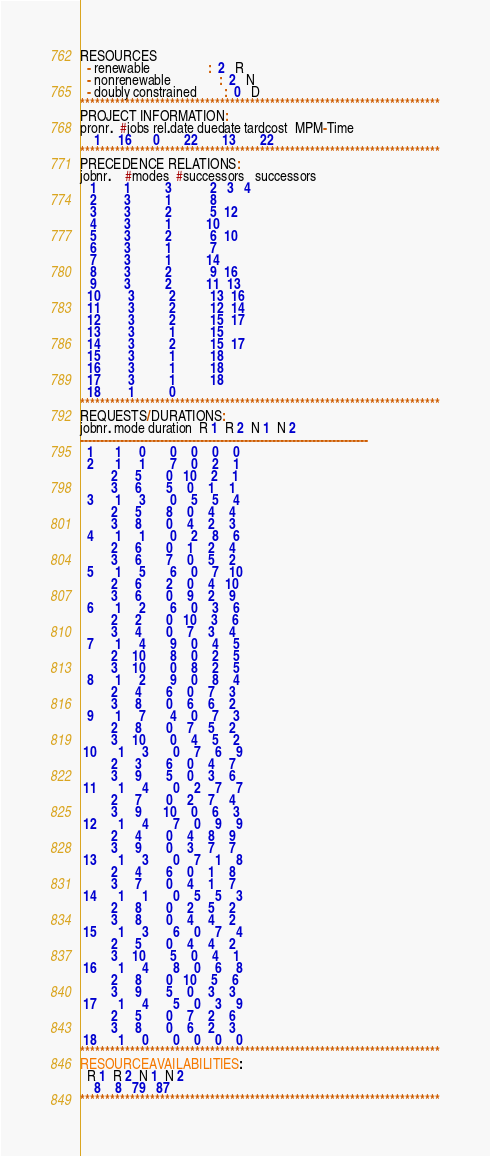Convert code to text. <code><loc_0><loc_0><loc_500><loc_500><_ObjectiveC_>RESOURCES
  - renewable                 :  2   R
  - nonrenewable              :  2   N
  - doubly constrained        :  0   D
************************************************************************
PROJECT INFORMATION:
pronr.  #jobs rel.date duedate tardcost  MPM-Time
    1     16      0       22       13       22
************************************************************************
PRECEDENCE RELATIONS:
jobnr.    #modes  #successors   successors
   1        1          3           2   3   4
   2        3          1           8
   3        3          2           5  12
   4        3          1          10
   5        3          2           6  10
   6        3          1           7
   7        3          1          14
   8        3          2           9  16
   9        3          2          11  13
  10        3          2          13  16
  11        3          2          12  14
  12        3          2          15  17
  13        3          1          15
  14        3          2          15  17
  15        3          1          18
  16        3          1          18
  17        3          1          18
  18        1          0        
************************************************************************
REQUESTS/DURATIONS:
jobnr. mode duration  R 1  R 2  N 1  N 2
------------------------------------------------------------------------
  1      1     0       0    0    0    0
  2      1     1       7    0    2    1
         2     5       0   10    2    1
         3     6       5    0    1    1
  3      1     3       0    5    5    4
         2     5       8    0    4    4
         3     8       0    4    2    3
  4      1     1       0    2    8    6
         2     6       0    1    2    4
         3     6       7    0    5    2
  5      1     5       6    0    7   10
         2     6       2    0    4   10
         3     6       0    9    2    9
  6      1     2       6    0    3    6
         2     2       0   10    3    6
         3     4       0    7    3    4
  7      1     4       9    0    4    5
         2    10       8    0    2    5
         3    10       0    8    2    5
  8      1     2       9    0    8    4
         2     4       6    0    7    3
         3     8       0    6    6    2
  9      1     7       4    0    7    3
         2     8       0    7    5    2
         3    10       0    4    5    2
 10      1     3       0    7    6    9
         2     3       6    0    4    7
         3     9       5    0    3    6
 11      1     4       0    2    7    7
         2     7       0    2    7    4
         3     9      10    0    6    3
 12      1     4       7    0    9    9
         2     4       0    4    8    9
         3     9       0    3    7    7
 13      1     3       0    7    1    8
         2     4       6    0    1    8
         3     7       0    4    1    7
 14      1     1       0    5    5    3
         2     8       0    2    5    2
         3     8       0    4    4    2
 15      1     3       6    0    7    4
         2     5       0    4    4    2
         3    10       5    0    4    1
 16      1     4       8    0    6    8
         2     8       0   10    5    6
         3     9       5    0    3    3
 17      1     4       5    0    3    9
         2     5       0    7    2    6
         3     8       0    6    2    3
 18      1     0       0    0    0    0
************************************************************************
RESOURCEAVAILABILITIES:
  R 1  R 2  N 1  N 2
    8    8   79   87
************************************************************************
</code> 